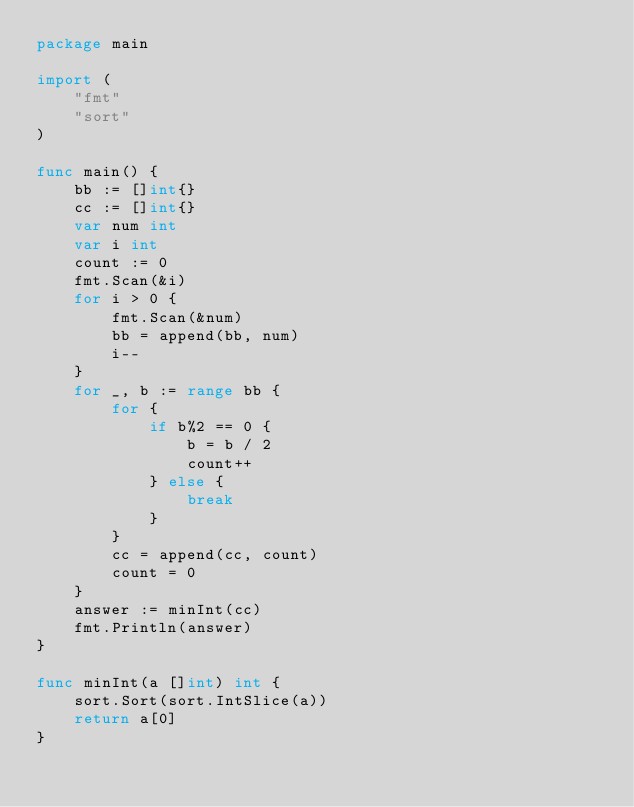<code> <loc_0><loc_0><loc_500><loc_500><_Go_>package main

import (
	"fmt"
	"sort"
)

func main() {
	bb := []int{}
	cc := []int{}
	var num int
	var i int
	count := 0
	fmt.Scan(&i)
	for i > 0 {
		fmt.Scan(&num)
		bb = append(bb, num)
		i--
	}
	for _, b := range bb {
		for {
			if b%2 == 0 {
				b = b / 2
				count++
			} else {
				break
			}
		}
		cc = append(cc, count)
		count = 0
	}
	answer := minInt(cc)
	fmt.Println(answer)
}

func minInt(a []int) int {
	sort.Sort(sort.IntSlice(a))
	return a[0]
}</code> 